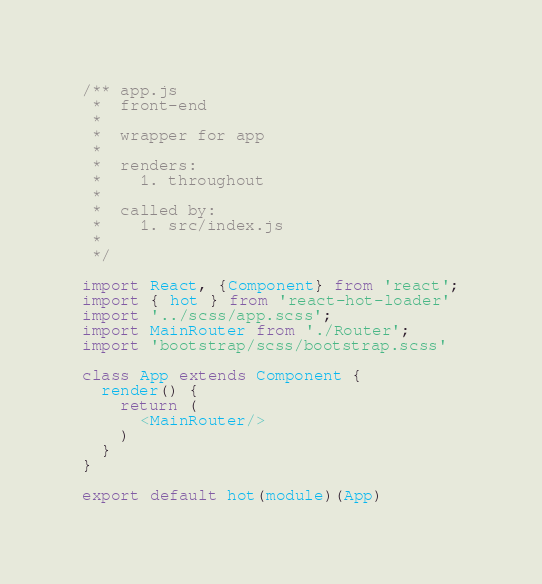<code> <loc_0><loc_0><loc_500><loc_500><_JavaScript_>/** app.js
 *  front-end
 * 
 *  wrapper for app
 *  
 *  renders:  
 *    1. throughout
 * 
 *  called by:
 *    1. src/index.js
 *    
 */

import React, {Component} from 'react';
import { hot } from 'react-hot-loader'
import '../scss/app.scss';
import MainRouter from './Router';
import 'bootstrap/scss/bootstrap.scss'

class App extends Component {
  render() {
    return (
      <MainRouter/>
    )
  }
}

export default hot(module)(App)
</code> 